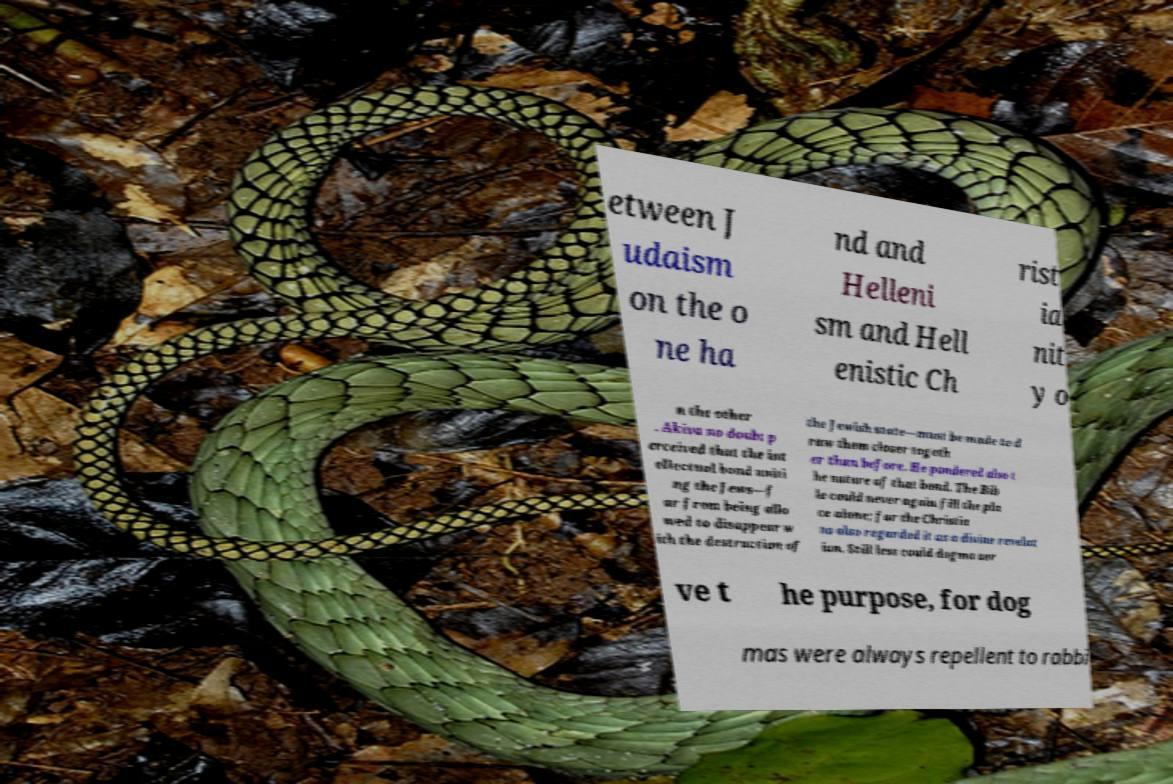I need the written content from this picture converted into text. Can you do that? etween J udaism on the o ne ha nd and Helleni sm and Hell enistic Ch rist ia nit y o n the other . Akiva no doubt p erceived that the int ellectual bond uniti ng the Jews—f ar from being allo wed to disappear w ith the destruction of the Jewish state—must be made to d raw them closer togeth er than before. He pondered also t he nature of that bond. The Bib le could never again fill the pla ce alone; for the Christia ns also regarded it as a divine revelat ion. Still less could dogma ser ve t he purpose, for dog mas were always repellent to rabbi 